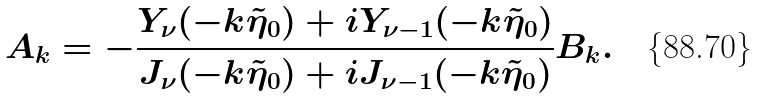Convert formula to latex. <formula><loc_0><loc_0><loc_500><loc_500>A _ { k } = - \frac { Y _ { \nu } ( - k \tilde { \eta } _ { 0 } ) + i Y _ { \nu - 1 } ( - k \tilde { \eta } _ { 0 } ) } { J _ { \nu } ( - k \tilde { \eta } _ { 0 } ) + i J _ { \nu - 1 } ( - k \tilde { \eta } _ { 0 } ) } B _ { k } .</formula> 